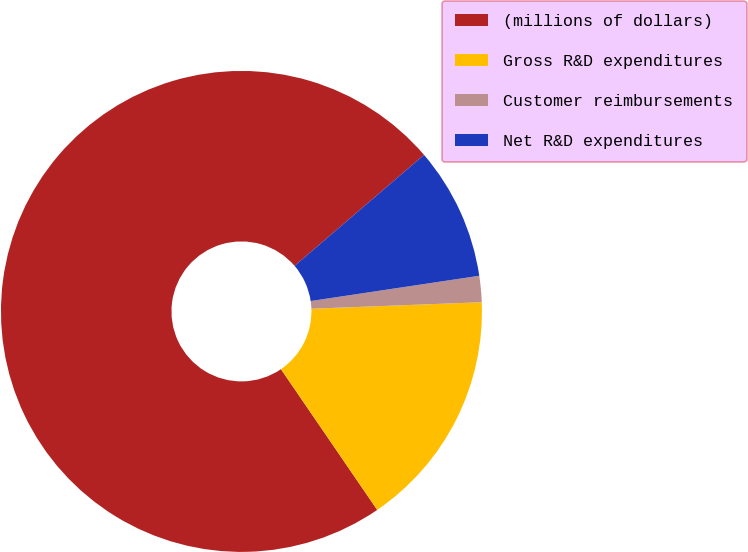Convert chart to OTSL. <chart><loc_0><loc_0><loc_500><loc_500><pie_chart><fcel>(millions of dollars)<fcel>Gross R&D expenditures<fcel>Customer reimbursements<fcel>Net R&D expenditures<nl><fcel>73.27%<fcel>16.06%<fcel>1.76%<fcel>8.91%<nl></chart> 